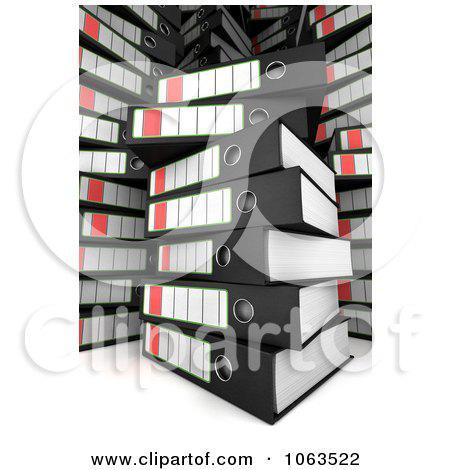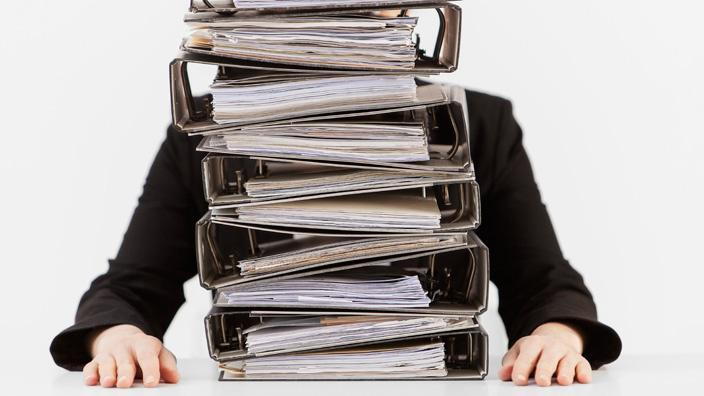The first image is the image on the left, the second image is the image on the right. For the images displayed, is the sentence "There is a person behind a stack of binders." factually correct? Answer yes or no. Yes. The first image is the image on the left, the second image is the image on the right. Evaluate the accuracy of this statement regarding the images: "The right image contains a stack of binders with a person sitting behind it.". Is it true? Answer yes or no. Yes. 